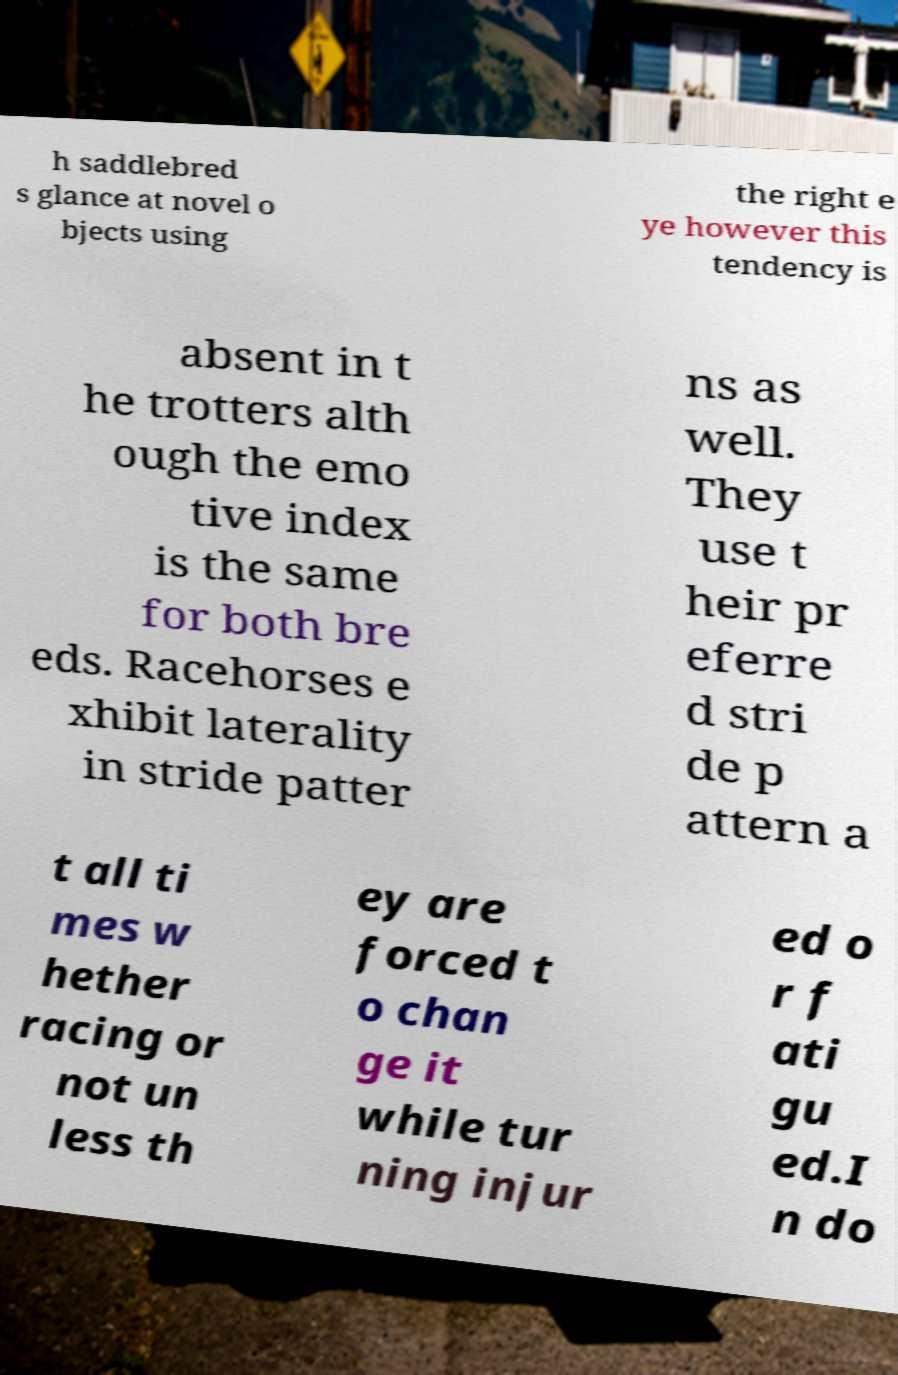For documentation purposes, I need the text within this image transcribed. Could you provide that? h saddlebred s glance at novel o bjects using the right e ye however this tendency is absent in t he trotters alth ough the emo tive index is the same for both bre eds. Racehorses e xhibit laterality in stride patter ns as well. They use t heir pr eferre d stri de p attern a t all ti mes w hether racing or not un less th ey are forced t o chan ge it while tur ning injur ed o r f ati gu ed.I n do 